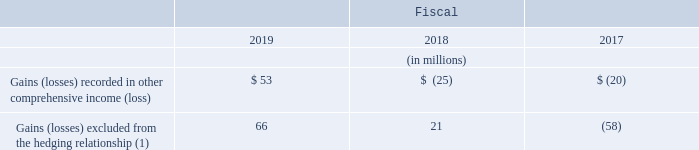Foreign Currency Exchange Rate Risk
As part of managing the exposure to changes in foreign currency exchange rates, we utilize cross-currency swap contracts and foreign currency forward contracts, a portion of which are designated as cash flow hedges. The objective of these contracts is to minimize impacts to cash flows and profitability due to changes in foreign currency exchange rates on intercompany and other cash transactions. We expect that significantly all of the balance in accumulated other comprehensive income (loss) associated with the cash flow hedge-designated instruments addressing foreign exchange risks will be reclassified into the Consolidated Statement of Operations within the next twelve months.
During fiscal 2015, we entered into cross-currency swap contracts with an aggregate notional value of €1,000 million to reduce our exposure to foreign currency exchange rate risk associated with certain intercompany loans. Under the terms of these contracts, which have been designated as cash flow hedges, we make interest payments in euros at 3.50% per annum and receive interest in U.S. dollars at a weighted-average rate of 5.33% per annum. Upon the maturity of these contracts in fiscal 2022, we will pay the notional value of the contracts in euros and receive U.S. dollars from our counterparties. In connection with the cross-currency swap contracts, both counterparties to each contract are required to provide cash collateral.
At fiscal year end 2019, these cross-currency swap contracts were in an asset position of $19 million and were recorded in other assets on the Consolidated Balance Sheet. The cross-currency swap contracts were in a liability position of $100 million and were recorded in other liabilities on the Consolidated Balance Sheet at fiscal year end 2018. At fiscal year end 2019 and 2018, collateral received from or paid to our counterparties approximated the derivative positions and was recorded in accrued and other current liabilities (when the contracts are in an asset position) or prepaid expenses and other current assets (when the contracts are in a liability position) on the Consolidated Balance Sheets. The impacts of these cross-currency swap contracts were as follows:
(1) Gains and losses excluded from the hedging relationship are recognized prospectively in selling, general, and administrative expenses and are offset by losses and gains generated as a result of re-measuring certain intercompany loans to the U.S. dollar.
How are Gains and losses excluded from the hedging relationship recognized? Recognized prospectively in selling, general, and administrative expenses and are offset by losses and gains generated as a result of re-measuring certain intercompany loans to the u.s. dollar. What was the liability position of the cross-currency swap contracts?  $100 million. What are the components of the impacts of cross-currency swap contracts in the table? Gains (losses) recorded in other comprehensive income (loss), gains (losses) excluded from the hedging relationship. In which year was the Gains excluded from the hedging relationship the largest? 66>21>-58
Answer: 2019. What was the change in Gains excluded from the hedging relationship in 2019 from 2018?
Answer scale should be: million. 66-21
Answer: 45. What was the percentage change in Gains excluded from the hedging relationship in 2019 from 2018?
Answer scale should be: percent. (66-21)/21
Answer: 214.29. 